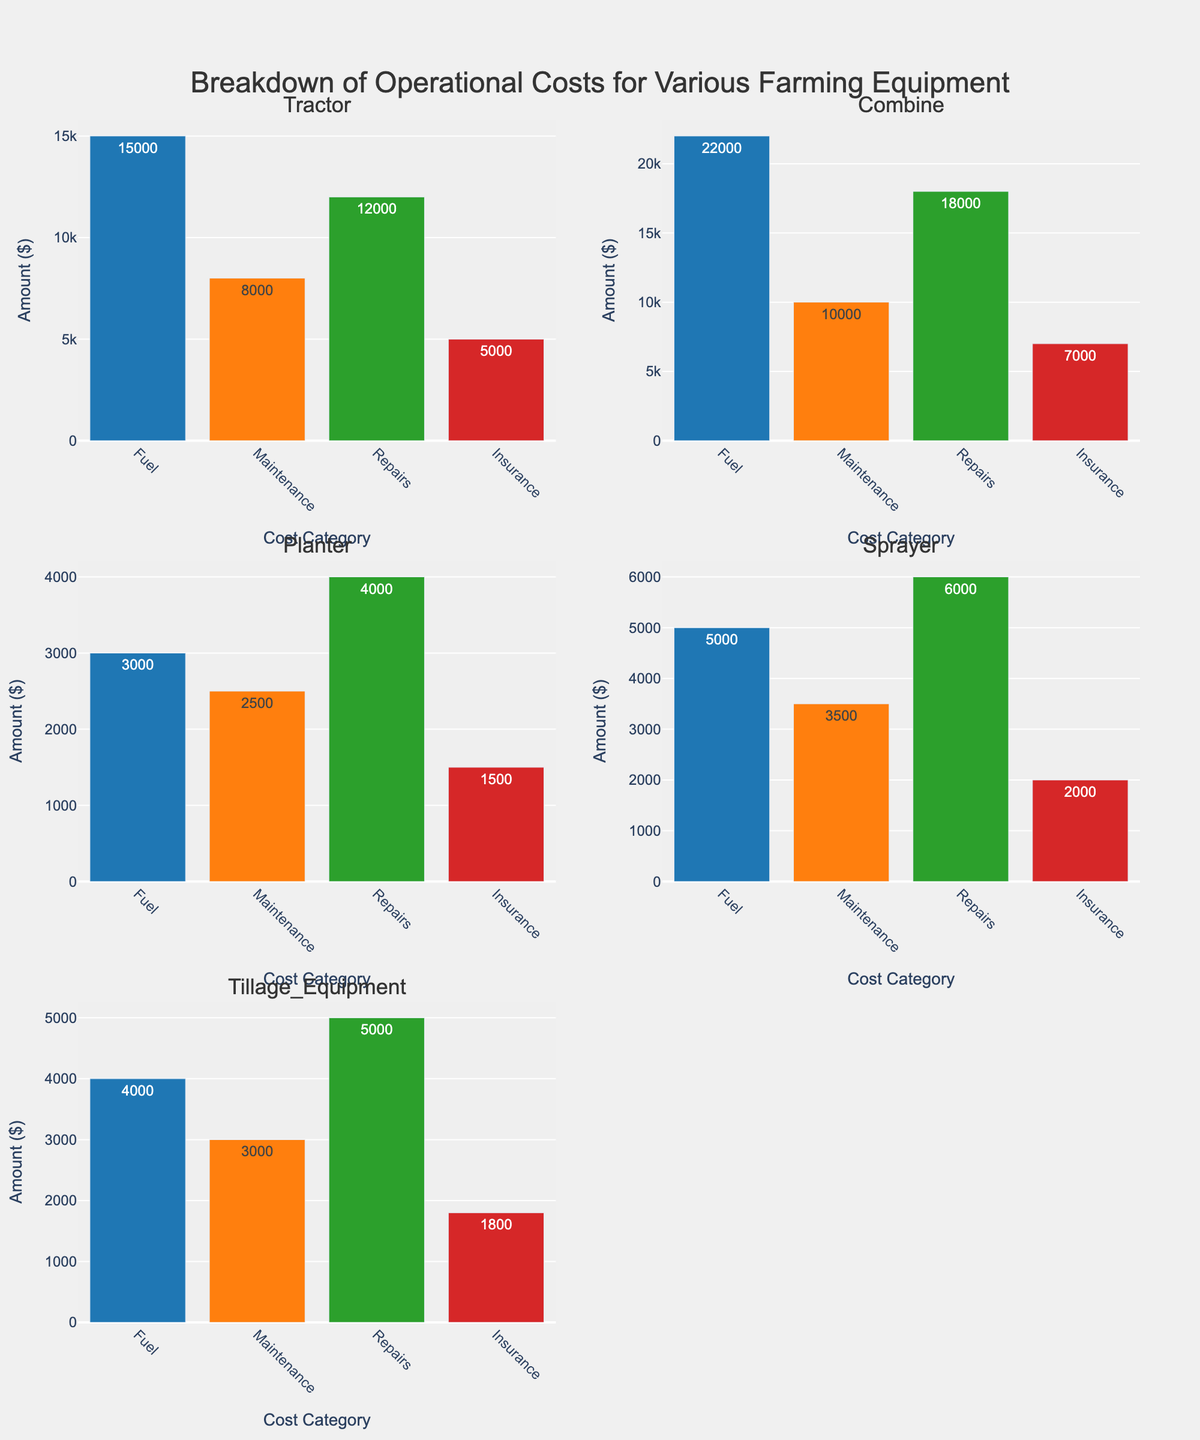What's the total operational cost for the Tractor? Sum up all the amounts under the Tractor's bar which cover Fuel ($15,000), Maintenance ($8,000), Repairs ($12,000), and Insurance ($5,000). The total is 15,000 + 8,000 + 12,000 + 5,000 = $40,000
Answer: $40,000 Which equipment has the highest cost for Fuel? Look at each subplot and find the bar labeled 'Fuel'. Compare the Fuel amounts across all equipment to identify the highest value, which is for the Combine at $22,000
Answer: Combine What is the difference between Repairs cost for Planter and Sprayer? Note the Repairs cost for Planter ($4,000) and Sprayer ($6,000). Subtract the lower cost from the higher cost: 6,000 - 4,000 = $2,000
Answer: $2,000 Which equipment has the lowest overall operational cost? Sum up the costs for each equipment and compare the totals. The Planter has the lowest total: 3,000 (Fuel) + 2,500 (Maintenance) + 4,000 (Repairs) + 1,500 (Insurance) = $11,000
Answer: Planter What is the average maintenance cost across all equipment? Add up the Maintenance costs for all equipment: 8,000 (Tractor) + 10,000 (Combine) + 2,500 (Planter) + 3,500 (Sprayer) + 3,000 (Tillage Equipment) = 27,000. Divide by the number of equipment (5): 27,000 / 5 = $5,400
Answer: $5,400 How does the Insurance cost for Combine compare to the Insurance cost for Tillage Equipment? Check the Insurance costs for Combine ($7,000) and Tillage Equipment ($1,800). The Combine's Insurance cost is higher: 7,000 > 1,800
Answer: Combine's Insurance cost is higher What is the sum of Maintenance and Repairs costs for Sprayer? Add the Maintenance and Repairs costs for Sprayer: 3,500 (Maintenance) + 6,000 (Repairs) = $9,500
Answer: $9,500 Which cost category shows the most consistent cost across all equipment? Compare the variance in each cost category across all equipment. Fuel, Maintenance, Repairs, and Insurance have different variances. Maintenance shows the smallest range from $2,500 to $10,000, suggesting more consistency
Answer: Maintenance What is the ratio of Repair costs between the Combine and the Planter? Divide the Repairs cost for Combine ($18,000) by the Repairs cost for Planter ($4,000). 18,000 / 4,000 = 4.5
Answer: 4.5 Between Tractor and Sprayer, which equipment has a higher Fuel cost and by how much? Check the Fuel costs for Tractor ($15,000) and Sprayer ($5,000). Subtract the lower cost: 15,000 - 5,000 = $10,000
Answer: Tractor by $10,000 